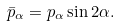<formula> <loc_0><loc_0><loc_500><loc_500>\bar { p } _ { \alpha } = p _ { \alpha } \sin 2 \alpha .</formula> 